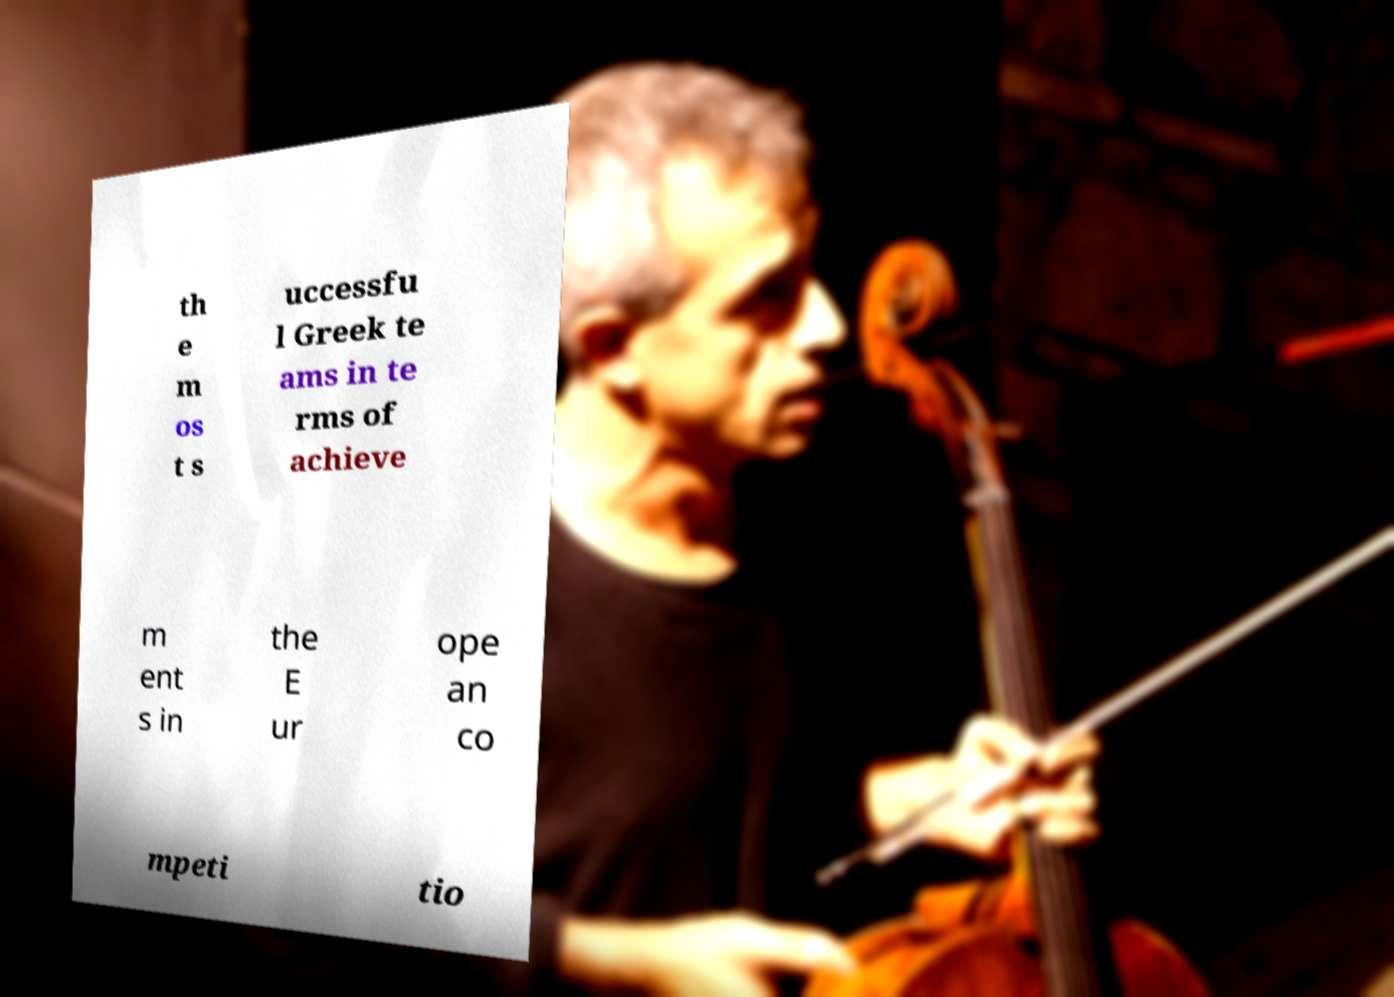There's text embedded in this image that I need extracted. Can you transcribe it verbatim? th e m os t s uccessfu l Greek te ams in te rms of achieve m ent s in the E ur ope an co mpeti tio 